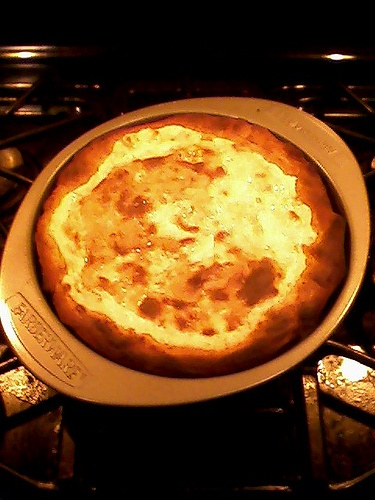Describe the objects in this image and their specific colors. I can see a pizza in black, khaki, orange, red, and brown tones in this image. 